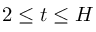<formula> <loc_0><loc_0><loc_500><loc_500>2 \leq t \leq H</formula> 